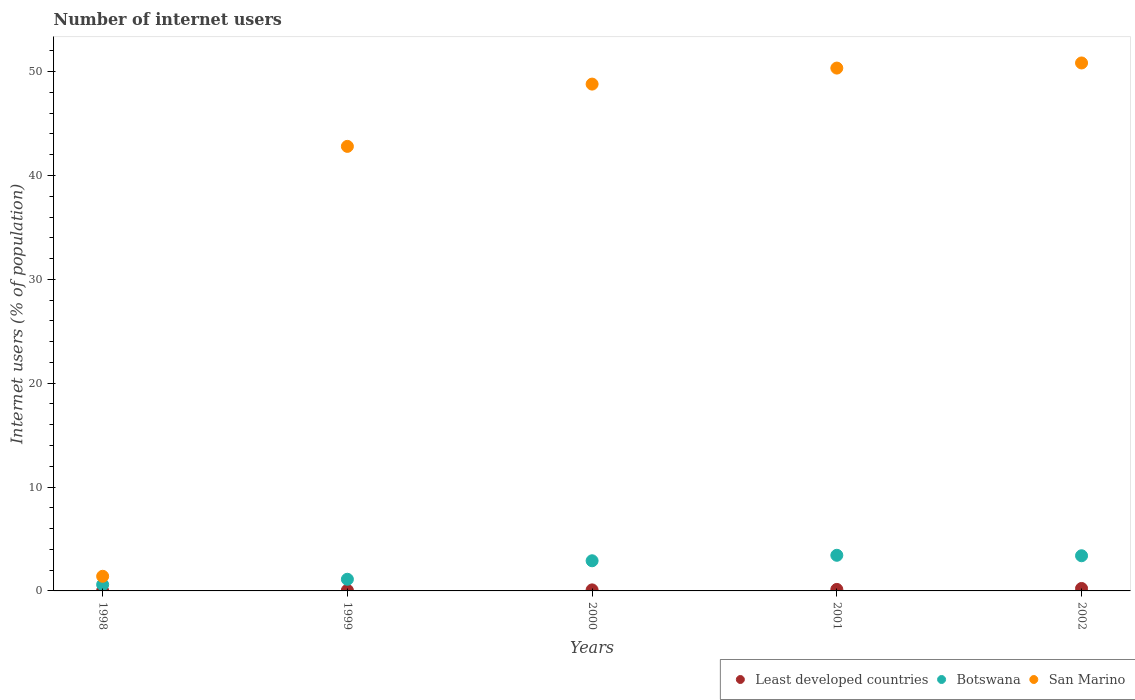How many different coloured dotlines are there?
Provide a short and direct response. 3. Is the number of dotlines equal to the number of legend labels?
Your answer should be very brief. Yes. What is the number of internet users in Botswana in 2001?
Provide a short and direct response. 3.43. Across all years, what is the maximum number of internet users in Least developed countries?
Make the answer very short. 0.24. Across all years, what is the minimum number of internet users in Botswana?
Provide a short and direct response. 0.6. In which year was the number of internet users in Botswana maximum?
Your answer should be very brief. 2001. In which year was the number of internet users in San Marino minimum?
Give a very brief answer. 1998. What is the total number of internet users in Botswana in the graph?
Provide a short and direct response. 11.44. What is the difference between the number of internet users in Least developed countries in 1998 and that in 2001?
Ensure brevity in your answer.  -0.12. What is the difference between the number of internet users in Least developed countries in 1998 and the number of internet users in San Marino in 2002?
Provide a succinct answer. -50.81. What is the average number of internet users in Least developed countries per year?
Ensure brevity in your answer.  0.11. In the year 2000, what is the difference between the number of internet users in Botswana and number of internet users in Least developed countries?
Give a very brief answer. 2.8. What is the ratio of the number of internet users in San Marino in 1999 to that in 2000?
Your response must be concise. 0.88. What is the difference between the highest and the second highest number of internet users in Botswana?
Your response must be concise. 0.04. What is the difference between the highest and the lowest number of internet users in Least developed countries?
Provide a short and direct response. 0.22. Does the number of internet users in Botswana monotonically increase over the years?
Offer a terse response. No. Is the number of internet users in Botswana strictly greater than the number of internet users in San Marino over the years?
Offer a very short reply. No. Where does the legend appear in the graph?
Ensure brevity in your answer.  Bottom right. How many legend labels are there?
Keep it short and to the point. 3. How are the legend labels stacked?
Your answer should be compact. Horizontal. What is the title of the graph?
Keep it short and to the point. Number of internet users. Does "OECD members" appear as one of the legend labels in the graph?
Keep it short and to the point. No. What is the label or title of the X-axis?
Keep it short and to the point. Years. What is the label or title of the Y-axis?
Ensure brevity in your answer.  Internet users (% of population). What is the Internet users (% of population) in Least developed countries in 1998?
Keep it short and to the point. 0.02. What is the Internet users (% of population) of Botswana in 1998?
Offer a terse response. 0.6. What is the Internet users (% of population) in San Marino in 1998?
Keep it short and to the point. 1.41. What is the Internet users (% of population) of Least developed countries in 1999?
Offer a terse response. 0.06. What is the Internet users (% of population) in Botswana in 1999?
Offer a terse response. 1.12. What is the Internet users (% of population) of San Marino in 1999?
Provide a short and direct response. 42.8. What is the Internet users (% of population) of Least developed countries in 2000?
Your response must be concise. 0.1. What is the Internet users (% of population) in Botswana in 2000?
Keep it short and to the point. 2.9. What is the Internet users (% of population) of San Marino in 2000?
Your response must be concise. 48.8. What is the Internet users (% of population) in Least developed countries in 2001?
Make the answer very short. 0.14. What is the Internet users (% of population) in Botswana in 2001?
Provide a short and direct response. 3.43. What is the Internet users (% of population) of San Marino in 2001?
Your answer should be very brief. 50.34. What is the Internet users (% of population) of Least developed countries in 2002?
Keep it short and to the point. 0.24. What is the Internet users (% of population) in Botswana in 2002?
Your answer should be compact. 3.39. What is the Internet users (% of population) of San Marino in 2002?
Provide a short and direct response. 50.83. Across all years, what is the maximum Internet users (% of population) of Least developed countries?
Your answer should be compact. 0.24. Across all years, what is the maximum Internet users (% of population) in Botswana?
Your answer should be very brief. 3.43. Across all years, what is the maximum Internet users (% of population) in San Marino?
Offer a very short reply. 50.83. Across all years, what is the minimum Internet users (% of population) in Least developed countries?
Give a very brief answer. 0.02. Across all years, what is the minimum Internet users (% of population) of Botswana?
Provide a succinct answer. 0.6. Across all years, what is the minimum Internet users (% of population) in San Marino?
Give a very brief answer. 1.41. What is the total Internet users (% of population) in Least developed countries in the graph?
Your answer should be very brief. 0.56. What is the total Internet users (% of population) in Botswana in the graph?
Your answer should be compact. 11.44. What is the total Internet users (% of population) in San Marino in the graph?
Keep it short and to the point. 194.19. What is the difference between the Internet users (% of population) of Least developed countries in 1998 and that in 1999?
Offer a terse response. -0.04. What is the difference between the Internet users (% of population) of Botswana in 1998 and that in 1999?
Keep it short and to the point. -0.52. What is the difference between the Internet users (% of population) in San Marino in 1998 and that in 1999?
Provide a short and direct response. -41.39. What is the difference between the Internet users (% of population) in Least developed countries in 1998 and that in 2000?
Make the answer very short. -0.08. What is the difference between the Internet users (% of population) of Botswana in 1998 and that in 2000?
Give a very brief answer. -2.3. What is the difference between the Internet users (% of population) of San Marino in 1998 and that in 2000?
Your response must be concise. -47.39. What is the difference between the Internet users (% of population) of Least developed countries in 1998 and that in 2001?
Make the answer very short. -0.12. What is the difference between the Internet users (% of population) of Botswana in 1998 and that in 2001?
Offer a very short reply. -2.83. What is the difference between the Internet users (% of population) of San Marino in 1998 and that in 2001?
Your answer should be very brief. -48.93. What is the difference between the Internet users (% of population) of Least developed countries in 1998 and that in 2002?
Your response must be concise. -0.22. What is the difference between the Internet users (% of population) of Botswana in 1998 and that in 2002?
Your answer should be very brief. -2.78. What is the difference between the Internet users (% of population) in San Marino in 1998 and that in 2002?
Provide a succinct answer. -49.43. What is the difference between the Internet users (% of population) of Least developed countries in 1999 and that in 2000?
Your response must be concise. -0.04. What is the difference between the Internet users (% of population) in Botswana in 1999 and that in 2000?
Offer a very short reply. -1.78. What is the difference between the Internet users (% of population) of San Marino in 1999 and that in 2000?
Ensure brevity in your answer.  -6. What is the difference between the Internet users (% of population) in Least developed countries in 1999 and that in 2001?
Offer a very short reply. -0.09. What is the difference between the Internet users (% of population) in Botswana in 1999 and that in 2001?
Your answer should be compact. -2.31. What is the difference between the Internet users (% of population) in San Marino in 1999 and that in 2001?
Provide a short and direct response. -7.54. What is the difference between the Internet users (% of population) of Least developed countries in 1999 and that in 2002?
Offer a terse response. -0.18. What is the difference between the Internet users (% of population) of Botswana in 1999 and that in 2002?
Your answer should be compact. -2.26. What is the difference between the Internet users (% of population) of San Marino in 1999 and that in 2002?
Provide a succinct answer. -8.03. What is the difference between the Internet users (% of population) of Least developed countries in 2000 and that in 2001?
Make the answer very short. -0.05. What is the difference between the Internet users (% of population) of Botswana in 2000 and that in 2001?
Keep it short and to the point. -0.53. What is the difference between the Internet users (% of population) of San Marino in 2000 and that in 2001?
Provide a succinct answer. -1.54. What is the difference between the Internet users (% of population) of Least developed countries in 2000 and that in 2002?
Make the answer very short. -0.14. What is the difference between the Internet users (% of population) of Botswana in 2000 and that in 2002?
Your response must be concise. -0.48. What is the difference between the Internet users (% of population) of San Marino in 2000 and that in 2002?
Give a very brief answer. -2.04. What is the difference between the Internet users (% of population) in Least developed countries in 2001 and that in 2002?
Your response must be concise. -0.09. What is the difference between the Internet users (% of population) in Botswana in 2001 and that in 2002?
Offer a terse response. 0.04. What is the difference between the Internet users (% of population) of San Marino in 2001 and that in 2002?
Offer a terse response. -0.49. What is the difference between the Internet users (% of population) in Least developed countries in 1998 and the Internet users (% of population) in Botswana in 1999?
Offer a terse response. -1.1. What is the difference between the Internet users (% of population) in Least developed countries in 1998 and the Internet users (% of population) in San Marino in 1999?
Give a very brief answer. -42.78. What is the difference between the Internet users (% of population) in Botswana in 1998 and the Internet users (% of population) in San Marino in 1999?
Keep it short and to the point. -42.2. What is the difference between the Internet users (% of population) in Least developed countries in 1998 and the Internet users (% of population) in Botswana in 2000?
Offer a terse response. -2.88. What is the difference between the Internet users (% of population) in Least developed countries in 1998 and the Internet users (% of population) in San Marino in 2000?
Make the answer very short. -48.78. What is the difference between the Internet users (% of population) of Botswana in 1998 and the Internet users (% of population) of San Marino in 2000?
Provide a succinct answer. -48.2. What is the difference between the Internet users (% of population) of Least developed countries in 1998 and the Internet users (% of population) of Botswana in 2001?
Ensure brevity in your answer.  -3.41. What is the difference between the Internet users (% of population) of Least developed countries in 1998 and the Internet users (% of population) of San Marino in 2001?
Provide a short and direct response. -50.32. What is the difference between the Internet users (% of population) in Botswana in 1998 and the Internet users (% of population) in San Marino in 2001?
Your answer should be very brief. -49.74. What is the difference between the Internet users (% of population) of Least developed countries in 1998 and the Internet users (% of population) of Botswana in 2002?
Your answer should be compact. -3.36. What is the difference between the Internet users (% of population) of Least developed countries in 1998 and the Internet users (% of population) of San Marino in 2002?
Give a very brief answer. -50.81. What is the difference between the Internet users (% of population) in Botswana in 1998 and the Internet users (% of population) in San Marino in 2002?
Offer a very short reply. -50.23. What is the difference between the Internet users (% of population) of Least developed countries in 1999 and the Internet users (% of population) of Botswana in 2000?
Provide a succinct answer. -2.85. What is the difference between the Internet users (% of population) in Least developed countries in 1999 and the Internet users (% of population) in San Marino in 2000?
Provide a succinct answer. -48.74. What is the difference between the Internet users (% of population) in Botswana in 1999 and the Internet users (% of population) in San Marino in 2000?
Your answer should be compact. -47.68. What is the difference between the Internet users (% of population) of Least developed countries in 1999 and the Internet users (% of population) of Botswana in 2001?
Provide a succinct answer. -3.37. What is the difference between the Internet users (% of population) in Least developed countries in 1999 and the Internet users (% of population) in San Marino in 2001?
Keep it short and to the point. -50.28. What is the difference between the Internet users (% of population) of Botswana in 1999 and the Internet users (% of population) of San Marino in 2001?
Make the answer very short. -49.22. What is the difference between the Internet users (% of population) of Least developed countries in 1999 and the Internet users (% of population) of Botswana in 2002?
Offer a terse response. -3.33. What is the difference between the Internet users (% of population) of Least developed countries in 1999 and the Internet users (% of population) of San Marino in 2002?
Offer a very short reply. -50.78. What is the difference between the Internet users (% of population) in Botswana in 1999 and the Internet users (% of population) in San Marino in 2002?
Offer a very short reply. -49.71. What is the difference between the Internet users (% of population) of Least developed countries in 2000 and the Internet users (% of population) of Botswana in 2001?
Offer a very short reply. -3.33. What is the difference between the Internet users (% of population) in Least developed countries in 2000 and the Internet users (% of population) in San Marino in 2001?
Offer a very short reply. -50.24. What is the difference between the Internet users (% of population) of Botswana in 2000 and the Internet users (% of population) of San Marino in 2001?
Your answer should be very brief. -47.44. What is the difference between the Internet users (% of population) of Least developed countries in 2000 and the Internet users (% of population) of Botswana in 2002?
Your answer should be compact. -3.29. What is the difference between the Internet users (% of population) of Least developed countries in 2000 and the Internet users (% of population) of San Marino in 2002?
Your answer should be compact. -50.74. What is the difference between the Internet users (% of population) of Botswana in 2000 and the Internet users (% of population) of San Marino in 2002?
Provide a short and direct response. -47.93. What is the difference between the Internet users (% of population) of Least developed countries in 2001 and the Internet users (% of population) of Botswana in 2002?
Your answer should be compact. -3.24. What is the difference between the Internet users (% of population) in Least developed countries in 2001 and the Internet users (% of population) in San Marino in 2002?
Provide a succinct answer. -50.69. What is the difference between the Internet users (% of population) of Botswana in 2001 and the Internet users (% of population) of San Marino in 2002?
Provide a short and direct response. -47.4. What is the average Internet users (% of population) in Least developed countries per year?
Provide a short and direct response. 0.11. What is the average Internet users (% of population) of Botswana per year?
Ensure brevity in your answer.  2.29. What is the average Internet users (% of population) of San Marino per year?
Provide a succinct answer. 38.84. In the year 1998, what is the difference between the Internet users (% of population) in Least developed countries and Internet users (% of population) in Botswana?
Offer a terse response. -0.58. In the year 1998, what is the difference between the Internet users (% of population) in Least developed countries and Internet users (% of population) in San Marino?
Provide a short and direct response. -1.39. In the year 1998, what is the difference between the Internet users (% of population) in Botswana and Internet users (% of population) in San Marino?
Your answer should be compact. -0.81. In the year 1999, what is the difference between the Internet users (% of population) in Least developed countries and Internet users (% of population) in Botswana?
Your answer should be compact. -1.07. In the year 1999, what is the difference between the Internet users (% of population) of Least developed countries and Internet users (% of population) of San Marino?
Your answer should be very brief. -42.75. In the year 1999, what is the difference between the Internet users (% of population) in Botswana and Internet users (% of population) in San Marino?
Offer a terse response. -41.68. In the year 2000, what is the difference between the Internet users (% of population) of Least developed countries and Internet users (% of population) of Botswana?
Keep it short and to the point. -2.8. In the year 2000, what is the difference between the Internet users (% of population) in Least developed countries and Internet users (% of population) in San Marino?
Provide a short and direct response. -48.7. In the year 2000, what is the difference between the Internet users (% of population) in Botswana and Internet users (% of population) in San Marino?
Keep it short and to the point. -45.9. In the year 2001, what is the difference between the Internet users (% of population) in Least developed countries and Internet users (% of population) in Botswana?
Your answer should be very brief. -3.29. In the year 2001, what is the difference between the Internet users (% of population) of Least developed countries and Internet users (% of population) of San Marino?
Give a very brief answer. -50.2. In the year 2001, what is the difference between the Internet users (% of population) of Botswana and Internet users (% of population) of San Marino?
Provide a succinct answer. -46.91. In the year 2002, what is the difference between the Internet users (% of population) of Least developed countries and Internet users (% of population) of Botswana?
Provide a short and direct response. -3.15. In the year 2002, what is the difference between the Internet users (% of population) of Least developed countries and Internet users (% of population) of San Marino?
Offer a terse response. -50.6. In the year 2002, what is the difference between the Internet users (% of population) in Botswana and Internet users (% of population) in San Marino?
Your answer should be compact. -47.45. What is the ratio of the Internet users (% of population) of Least developed countries in 1998 to that in 1999?
Your response must be concise. 0.37. What is the ratio of the Internet users (% of population) of Botswana in 1998 to that in 1999?
Your answer should be compact. 0.54. What is the ratio of the Internet users (% of population) in San Marino in 1998 to that in 1999?
Offer a terse response. 0.03. What is the ratio of the Internet users (% of population) in Least developed countries in 1998 to that in 2000?
Make the answer very short. 0.21. What is the ratio of the Internet users (% of population) in Botswana in 1998 to that in 2000?
Your answer should be very brief. 0.21. What is the ratio of the Internet users (% of population) in San Marino in 1998 to that in 2000?
Your answer should be compact. 0.03. What is the ratio of the Internet users (% of population) of Least developed countries in 1998 to that in 2001?
Ensure brevity in your answer.  0.15. What is the ratio of the Internet users (% of population) in Botswana in 1998 to that in 2001?
Your response must be concise. 0.18. What is the ratio of the Internet users (% of population) of San Marino in 1998 to that in 2001?
Give a very brief answer. 0.03. What is the ratio of the Internet users (% of population) in Least developed countries in 1998 to that in 2002?
Keep it short and to the point. 0.09. What is the ratio of the Internet users (% of population) in Botswana in 1998 to that in 2002?
Your answer should be very brief. 0.18. What is the ratio of the Internet users (% of population) of San Marino in 1998 to that in 2002?
Keep it short and to the point. 0.03. What is the ratio of the Internet users (% of population) in Least developed countries in 1999 to that in 2000?
Offer a very short reply. 0.58. What is the ratio of the Internet users (% of population) of Botswana in 1999 to that in 2000?
Your answer should be very brief. 0.39. What is the ratio of the Internet users (% of population) in San Marino in 1999 to that in 2000?
Offer a very short reply. 0.88. What is the ratio of the Internet users (% of population) in Least developed countries in 1999 to that in 2001?
Provide a short and direct response. 0.4. What is the ratio of the Internet users (% of population) in Botswana in 1999 to that in 2001?
Make the answer very short. 0.33. What is the ratio of the Internet users (% of population) of San Marino in 1999 to that in 2001?
Offer a very short reply. 0.85. What is the ratio of the Internet users (% of population) of Least developed countries in 1999 to that in 2002?
Give a very brief answer. 0.24. What is the ratio of the Internet users (% of population) in Botswana in 1999 to that in 2002?
Offer a very short reply. 0.33. What is the ratio of the Internet users (% of population) in San Marino in 1999 to that in 2002?
Your answer should be very brief. 0.84. What is the ratio of the Internet users (% of population) of Least developed countries in 2000 to that in 2001?
Provide a short and direct response. 0.69. What is the ratio of the Internet users (% of population) of Botswana in 2000 to that in 2001?
Offer a terse response. 0.85. What is the ratio of the Internet users (% of population) of San Marino in 2000 to that in 2001?
Provide a short and direct response. 0.97. What is the ratio of the Internet users (% of population) of Least developed countries in 2000 to that in 2002?
Keep it short and to the point. 0.42. What is the ratio of the Internet users (% of population) of Botswana in 2000 to that in 2002?
Your answer should be very brief. 0.86. What is the ratio of the Internet users (% of population) of Least developed countries in 2001 to that in 2002?
Make the answer very short. 0.61. What is the ratio of the Internet users (% of population) in Botswana in 2001 to that in 2002?
Provide a succinct answer. 1.01. What is the ratio of the Internet users (% of population) in San Marino in 2001 to that in 2002?
Provide a succinct answer. 0.99. What is the difference between the highest and the second highest Internet users (% of population) in Least developed countries?
Offer a very short reply. 0.09. What is the difference between the highest and the second highest Internet users (% of population) of Botswana?
Keep it short and to the point. 0.04. What is the difference between the highest and the second highest Internet users (% of population) in San Marino?
Ensure brevity in your answer.  0.49. What is the difference between the highest and the lowest Internet users (% of population) in Least developed countries?
Provide a short and direct response. 0.22. What is the difference between the highest and the lowest Internet users (% of population) of Botswana?
Offer a terse response. 2.83. What is the difference between the highest and the lowest Internet users (% of population) of San Marino?
Your response must be concise. 49.43. 